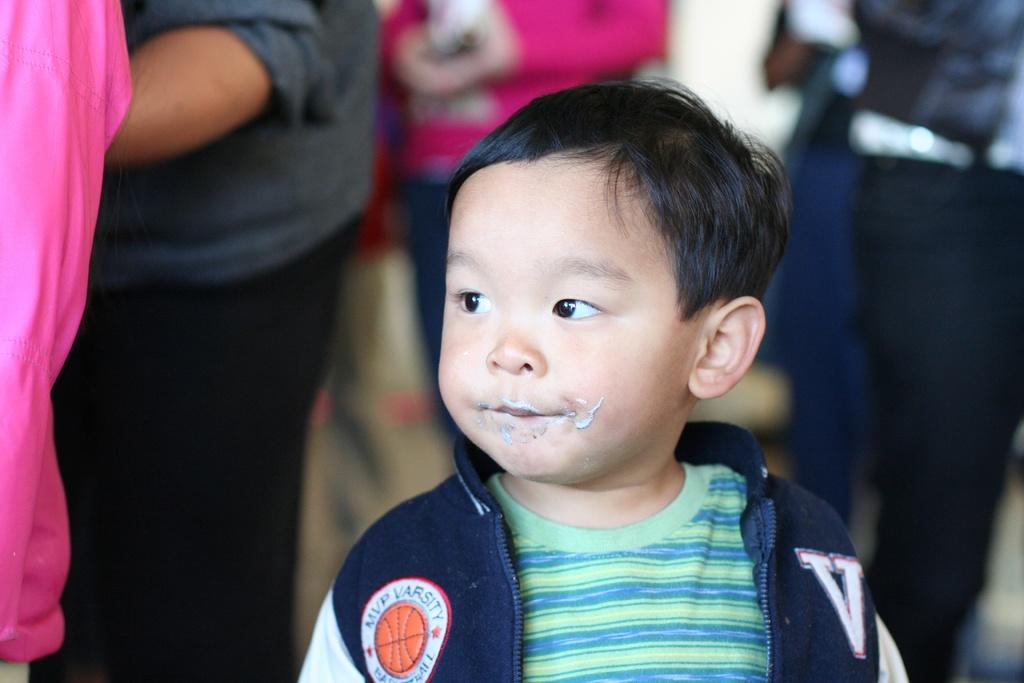What does the v on the child's jacket stand for?
Offer a very short reply. Varsity. What are the initials shown on the patch on the left side of the jacket?
Provide a succinct answer. V. 